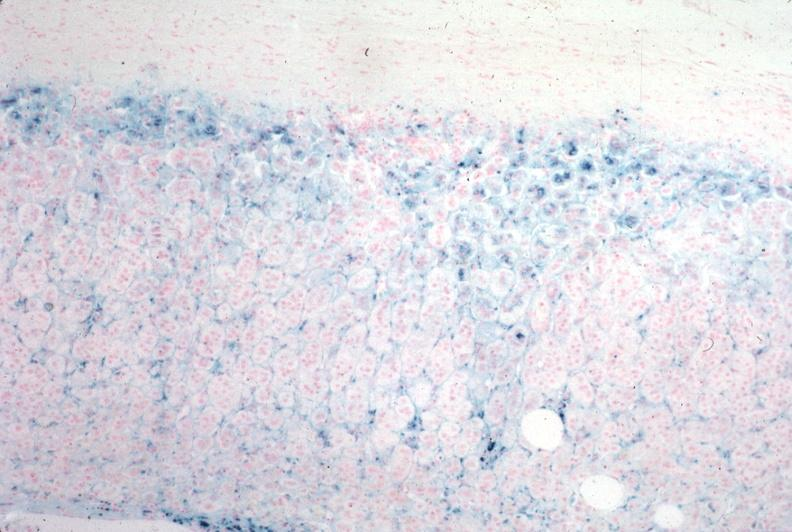does muscle atrophy stain?
Answer the question using a single word or phrase. No 